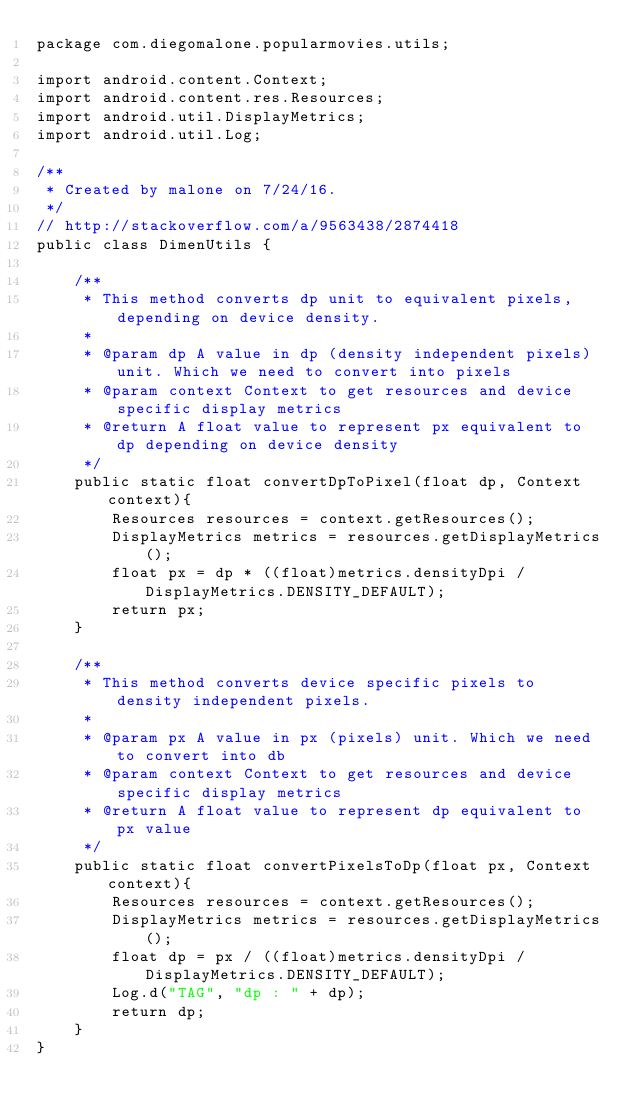<code> <loc_0><loc_0><loc_500><loc_500><_Java_>package com.diegomalone.popularmovies.utils;

import android.content.Context;
import android.content.res.Resources;
import android.util.DisplayMetrics;
import android.util.Log;

/**
 * Created by malone on 7/24/16.
 */
// http://stackoverflow.com/a/9563438/2874418
public class DimenUtils {

    /**
     * This method converts dp unit to equivalent pixels, depending on device density.
     *
     * @param dp A value in dp (density independent pixels) unit. Which we need to convert into pixels
     * @param context Context to get resources and device specific display metrics
     * @return A float value to represent px equivalent to dp depending on device density
     */
    public static float convertDpToPixel(float dp, Context context){
        Resources resources = context.getResources();
        DisplayMetrics metrics = resources.getDisplayMetrics();
        float px = dp * ((float)metrics.densityDpi / DisplayMetrics.DENSITY_DEFAULT);
        return px;
    }

    /**
     * This method converts device specific pixels to density independent pixels.
     *
     * @param px A value in px (pixels) unit. Which we need to convert into db
     * @param context Context to get resources and device specific display metrics
     * @return A float value to represent dp equivalent to px value
     */
    public static float convertPixelsToDp(float px, Context context){
        Resources resources = context.getResources();
        DisplayMetrics metrics = resources.getDisplayMetrics();
        float dp = px / ((float)metrics.densityDpi / DisplayMetrics.DENSITY_DEFAULT);
        Log.d("TAG", "dp : " + dp);
        return dp;
    }
}
</code> 